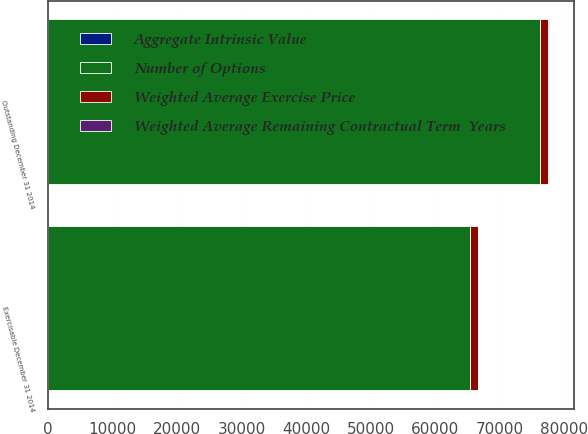Convert chart to OTSL. <chart><loc_0><loc_0><loc_500><loc_500><stacked_bar_chart><ecel><fcel>Outstanding December 31 2014<fcel>Exercisable December 31 2014<nl><fcel>Number of Options<fcel>76135<fcel>65324<nl><fcel>Weighted Average Remaining Contractual Term  Years<fcel>39.05<fcel>37.56<nl><fcel>Aggregate Intrinsic Value<fcel>3.85<fcel>3.21<nl><fcel>Weighted Average Exercise Price<fcel>1358<fcel>1257<nl></chart> 